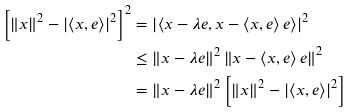Convert formula to latex. <formula><loc_0><loc_0><loc_500><loc_500>\left [ \left \| x \right \| ^ { 2 } - \left | \left \langle x , e \right \rangle \right | ^ { 2 } \right ] ^ { 2 } & = \left | \left \langle x - \lambda e , x - \left \langle x , e \right \rangle e \right \rangle \right | ^ { 2 } \\ & \leq \left \| x - \lambda e \right \| ^ { 2 } \left \| x - \left \langle x , e \right \rangle e \right \| ^ { 2 } \\ & = \left \| x - \lambda e \right \| ^ { 2 } \left [ \left \| x \right \| ^ { 2 } - \left | \left \langle x , e \right \rangle \right | ^ { 2 } \right ]</formula> 